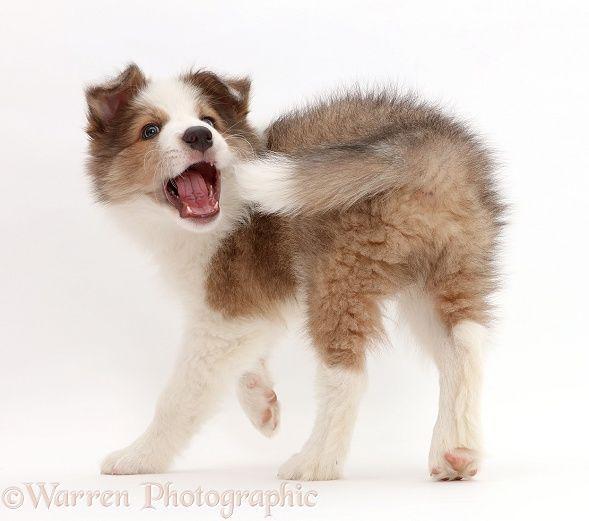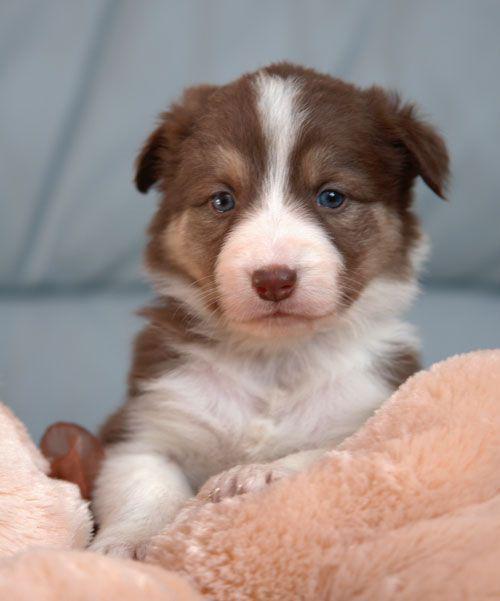The first image is the image on the left, the second image is the image on the right. Examine the images to the left and right. Is the description "The combined images include two brown-and-white dogs reclining with front paws extended forward." accurate? Answer yes or no. No. The first image is the image on the left, the second image is the image on the right. Analyze the images presented: Is the assertion "One brown and white dog has its mouth open with tongue showing and one does not, but both have wide white bands of color between their eyes." valid? Answer yes or no. Yes. 